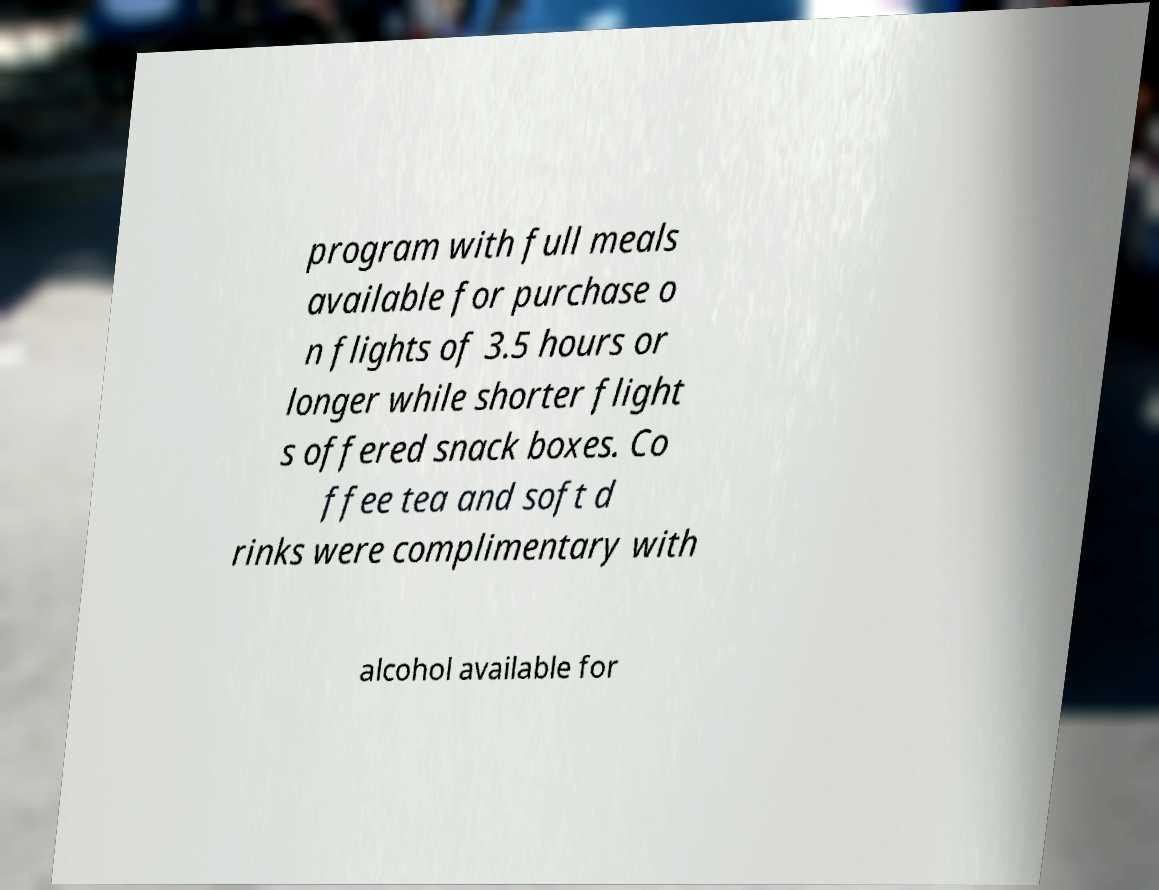Can you read and provide the text displayed in the image?This photo seems to have some interesting text. Can you extract and type it out for me? program with full meals available for purchase o n flights of 3.5 hours or longer while shorter flight s offered snack boxes. Co ffee tea and soft d rinks were complimentary with alcohol available for 